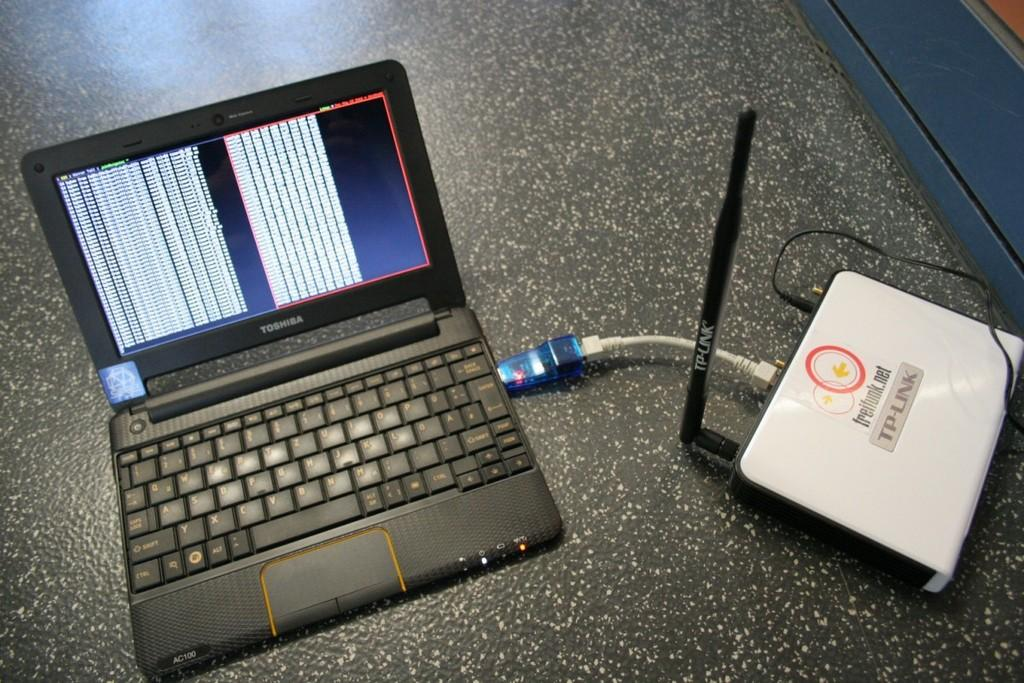<image>
Relay a brief, clear account of the picture shown. A Toshiba laptop is open and connected to anther device. 